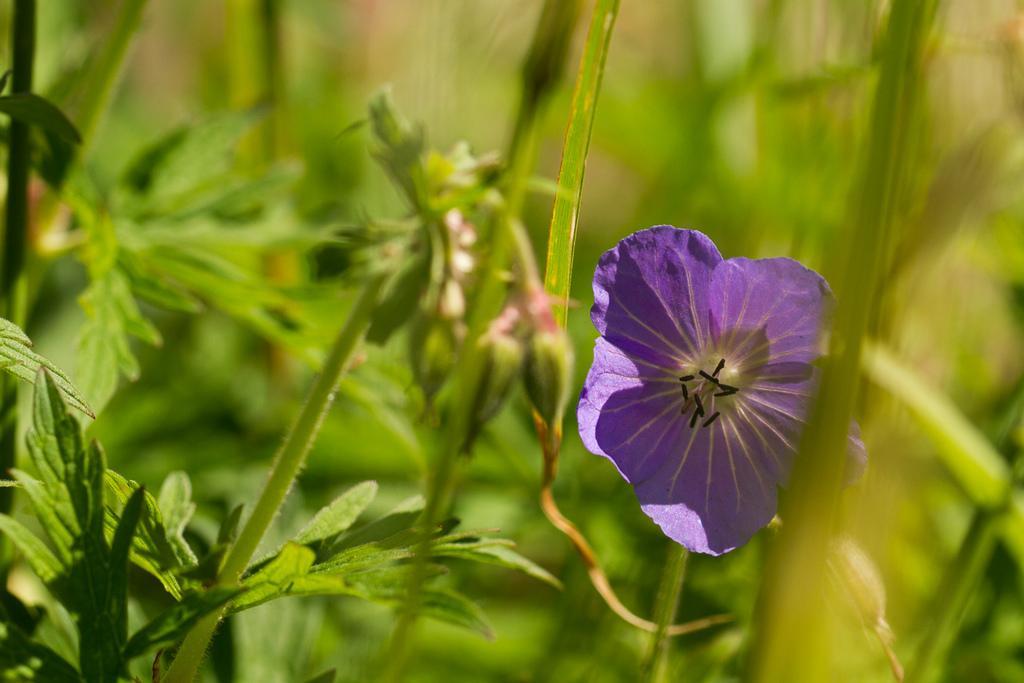Could you give a brief overview of what you see in this image? In this image we can see a flower and plants. 